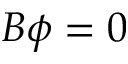<formula> <loc_0><loc_0><loc_500><loc_500>B \phi = 0</formula> 